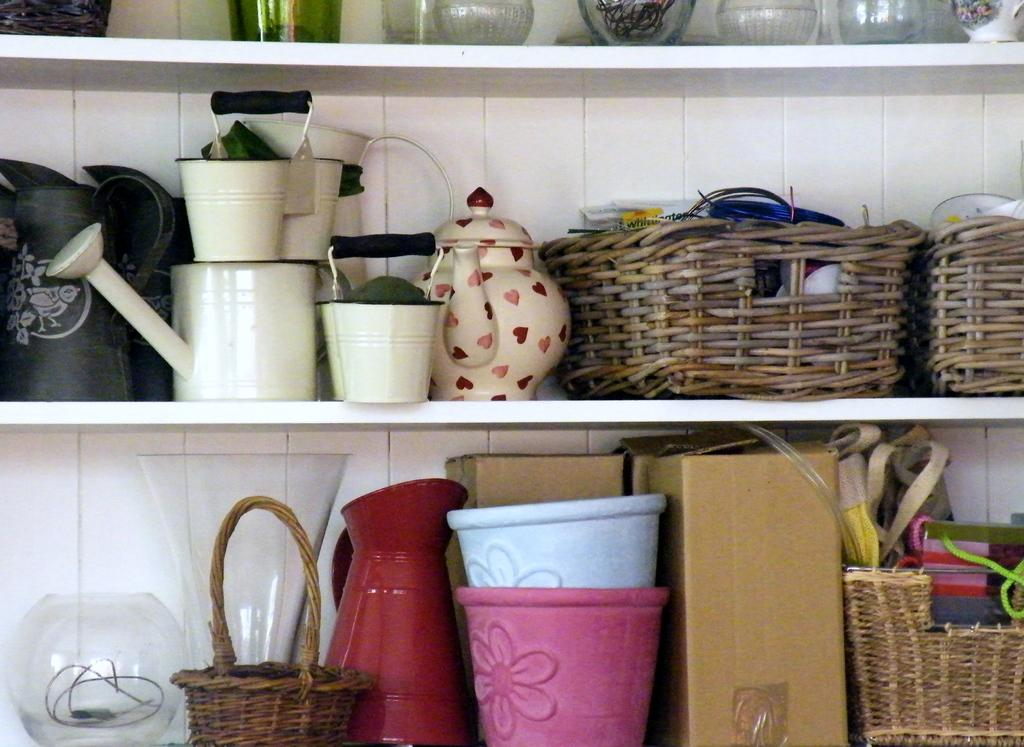What type of containers can be seen in the image? There are glass jars, flower vases, and glass vessels in the image. What other types of objects are present in the image? There is a vessel, cardboard boxes, baskets, a kettle, and a water bucket in the image. Where are these objects located in the image? All these objects are kept on shelves. What type of motion can be observed in the image? There is no motion observed in the image; all objects are stationary on the shelves. Are there any recesses or breaks in the shelves in the image? The provided facts do not mention any recesses or breaks in the shelves; only the objects placed on them are described. 